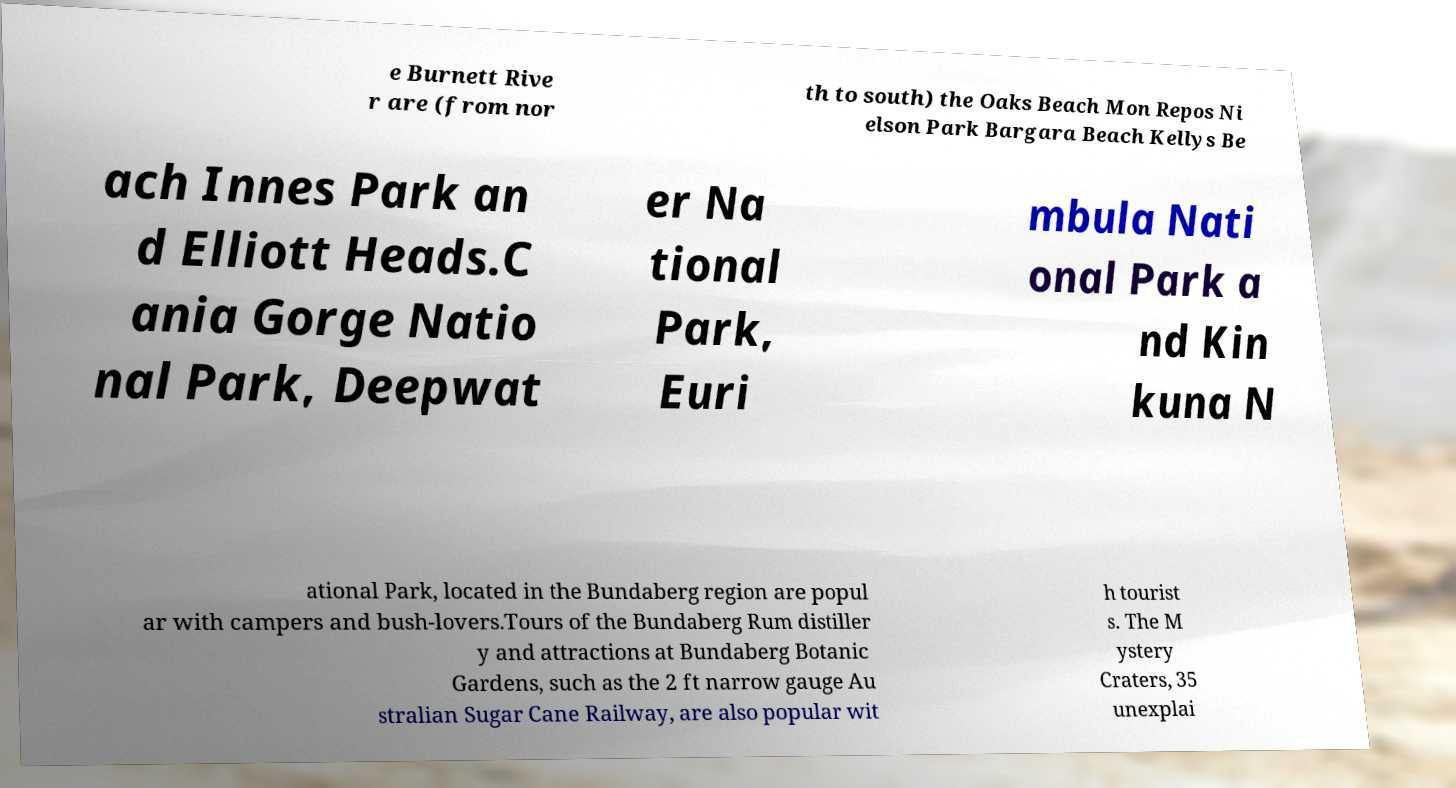Could you extract and type out the text from this image? e Burnett Rive r are (from nor th to south) the Oaks Beach Mon Repos Ni elson Park Bargara Beach Kellys Be ach Innes Park an d Elliott Heads.C ania Gorge Natio nal Park, Deepwat er Na tional Park, Euri mbula Nati onal Park a nd Kin kuna N ational Park, located in the Bundaberg region are popul ar with campers and bush-lovers.Tours of the Bundaberg Rum distiller y and attractions at Bundaberg Botanic Gardens, such as the 2 ft narrow gauge Au stralian Sugar Cane Railway, are also popular wit h tourist s. The M ystery Craters, 35 unexplai 